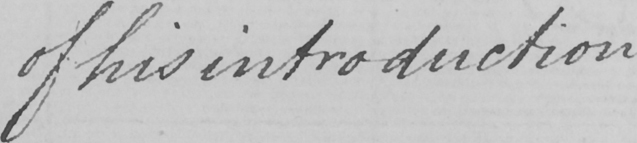Can you tell me what this handwritten text says? of his introduction . 